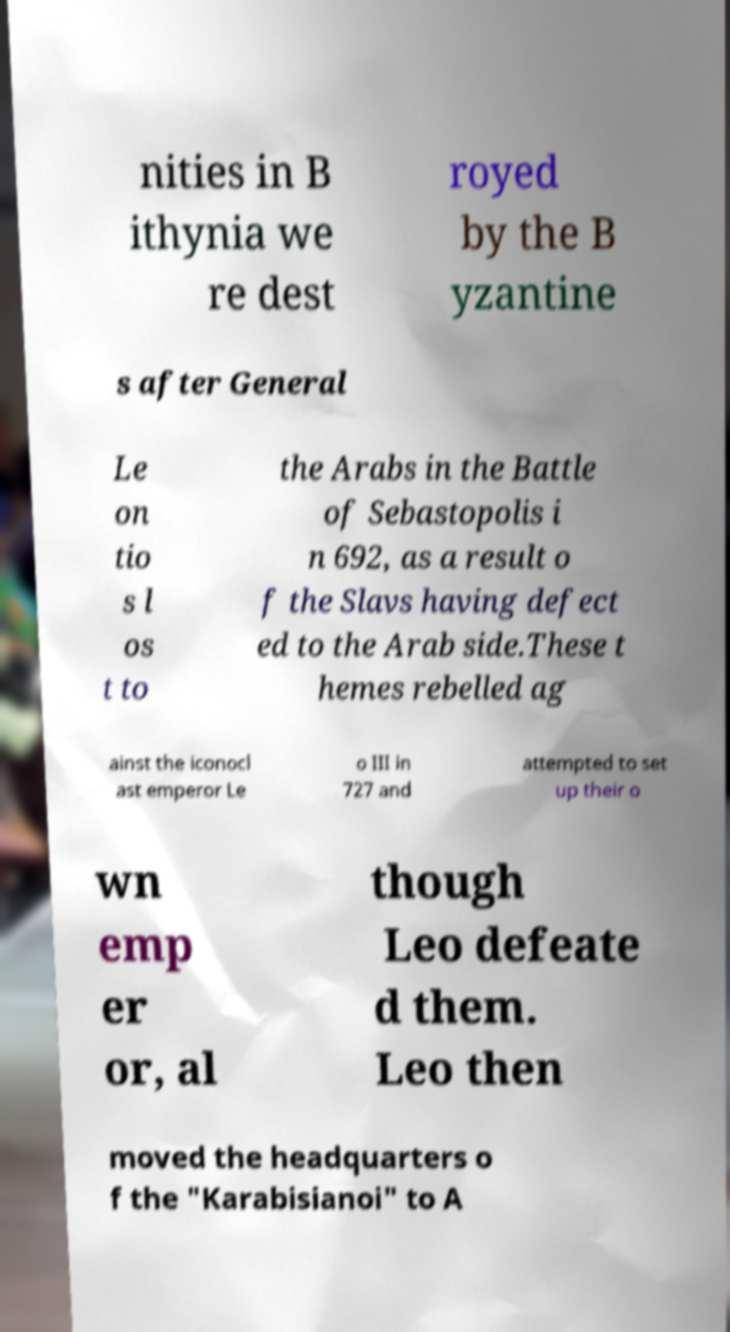I need the written content from this picture converted into text. Can you do that? nities in B ithynia we re dest royed by the B yzantine s after General Le on tio s l os t to the Arabs in the Battle of Sebastopolis i n 692, as a result o f the Slavs having defect ed to the Arab side.These t hemes rebelled ag ainst the iconocl ast emperor Le o III in 727 and attempted to set up their o wn emp er or, al though Leo defeate d them. Leo then moved the headquarters o f the "Karabisianoi" to A 